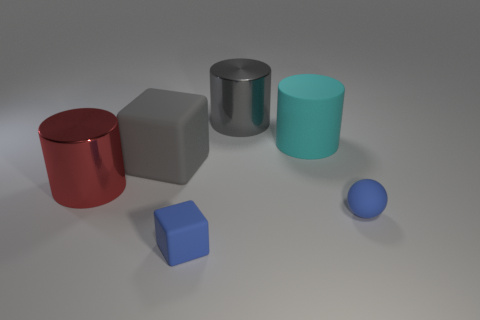Add 3 gray shiny objects. How many objects exist? 9 Subtract all cubes. How many objects are left? 4 Add 1 tiny blue matte balls. How many tiny blue matte balls are left? 2 Add 1 big gray shiny cylinders. How many big gray shiny cylinders exist? 2 Subtract 1 gray cubes. How many objects are left? 5 Subtract all matte balls. Subtract all small blue objects. How many objects are left? 3 